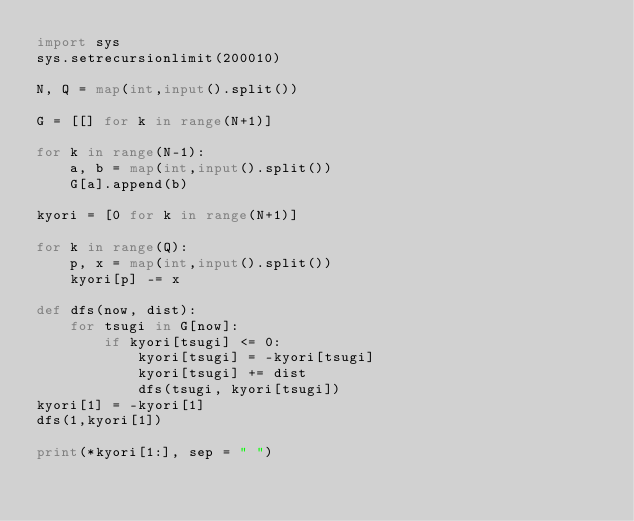Convert code to text. <code><loc_0><loc_0><loc_500><loc_500><_Python_>import sys
sys.setrecursionlimit(200010)

N, Q = map(int,input().split())

G = [[] for k in range(N+1)]

for k in range(N-1):
    a, b = map(int,input().split())
    G[a].append(b)

kyori = [0 for k in range(N+1)]

for k in range(Q):
    p, x = map(int,input().split())
    kyori[p] -= x

def dfs(now, dist):
    for tsugi in G[now]:
        if kyori[tsugi] <= 0:
            kyori[tsugi] = -kyori[tsugi]
            kyori[tsugi] += dist
            dfs(tsugi, kyori[tsugi])
kyori[1] = -kyori[1]
dfs(1,kyori[1])

print(*kyori[1:], sep = " ")
</code> 